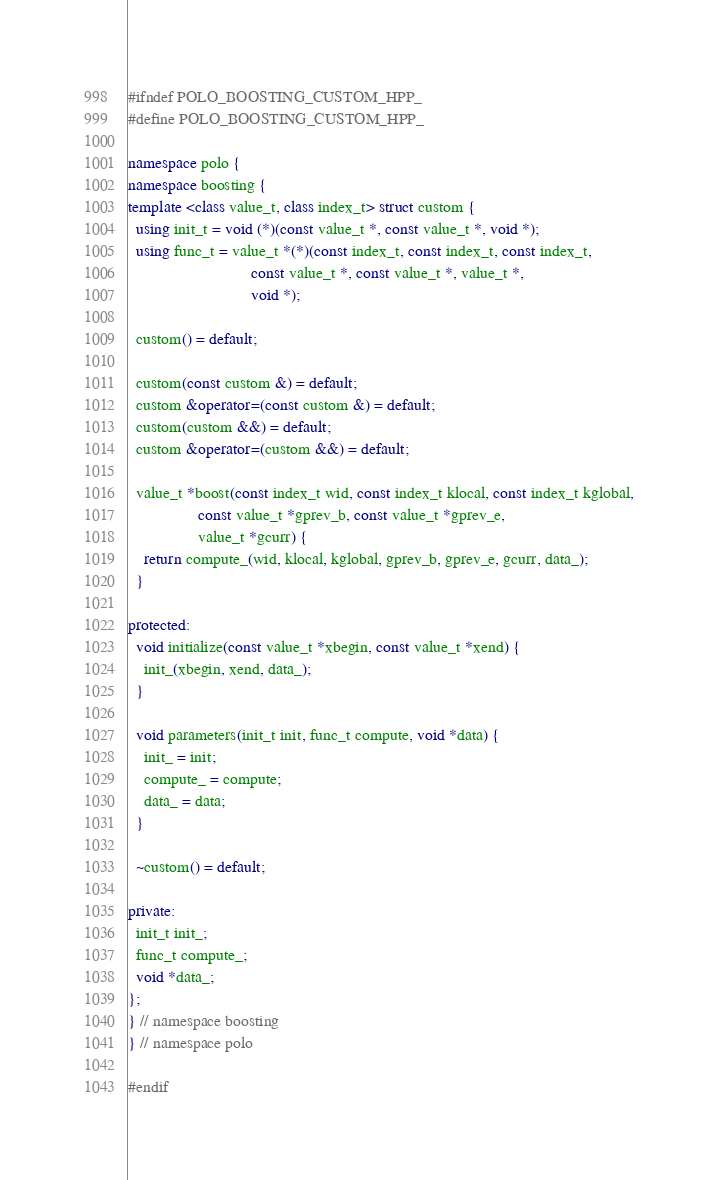Convert code to text. <code><loc_0><loc_0><loc_500><loc_500><_C++_>#ifndef POLO_BOOSTING_CUSTOM_HPP_
#define POLO_BOOSTING_CUSTOM_HPP_

namespace polo {
namespace boosting {
template <class value_t, class index_t> struct custom {
  using init_t = void (*)(const value_t *, const value_t *, void *);
  using func_t = value_t *(*)(const index_t, const index_t, const index_t,
                              const value_t *, const value_t *, value_t *,
                              void *);

  custom() = default;

  custom(const custom &) = default;
  custom &operator=(const custom &) = default;
  custom(custom &&) = default;
  custom &operator=(custom &&) = default;

  value_t *boost(const index_t wid, const index_t klocal, const index_t kglobal,
                 const value_t *gprev_b, const value_t *gprev_e,
                 value_t *gcurr) {
    return compute_(wid, klocal, kglobal, gprev_b, gprev_e, gcurr, data_);
  }

protected:
  void initialize(const value_t *xbegin, const value_t *xend) {
    init_(xbegin, xend, data_);
  }

  void parameters(init_t init, func_t compute, void *data) {
    init_ = init;
    compute_ = compute;
    data_ = data;
  }

  ~custom() = default;

private:
  init_t init_;
  func_t compute_;
  void *data_;
};
} // namespace boosting
} // namespace polo

#endif
</code> 